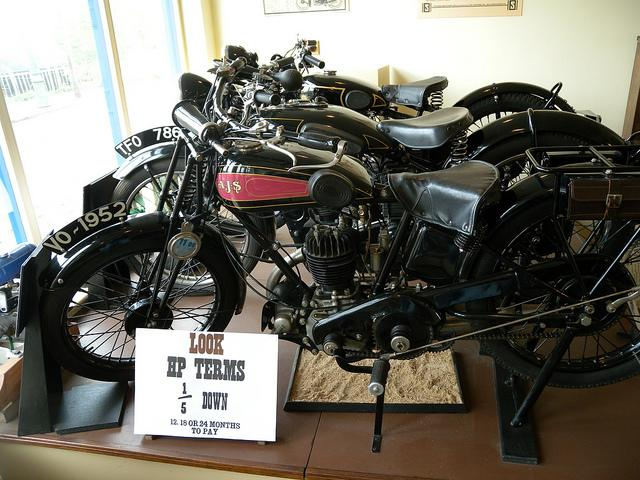What are the terms referring to?

Choices:
A) road rules
B) rider code
C) biker terms
D) financing financing 